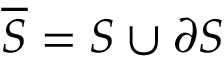Convert formula to latex. <formula><loc_0><loc_0><loc_500><loc_500>{ \overline { S } } = S \cup \partial S</formula> 